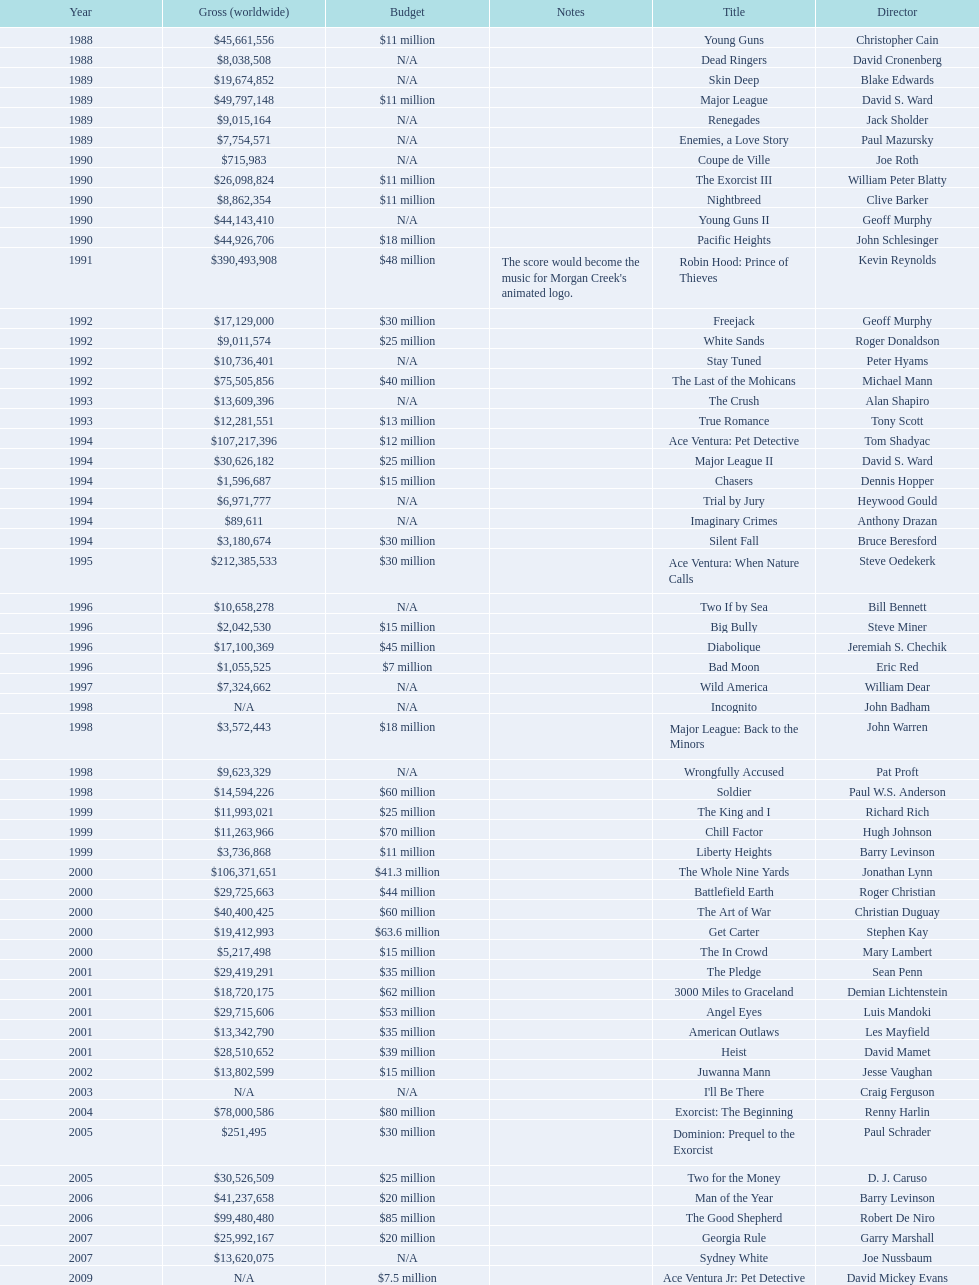What is the top grossing film? Robin Hood: Prince of Thieves. 